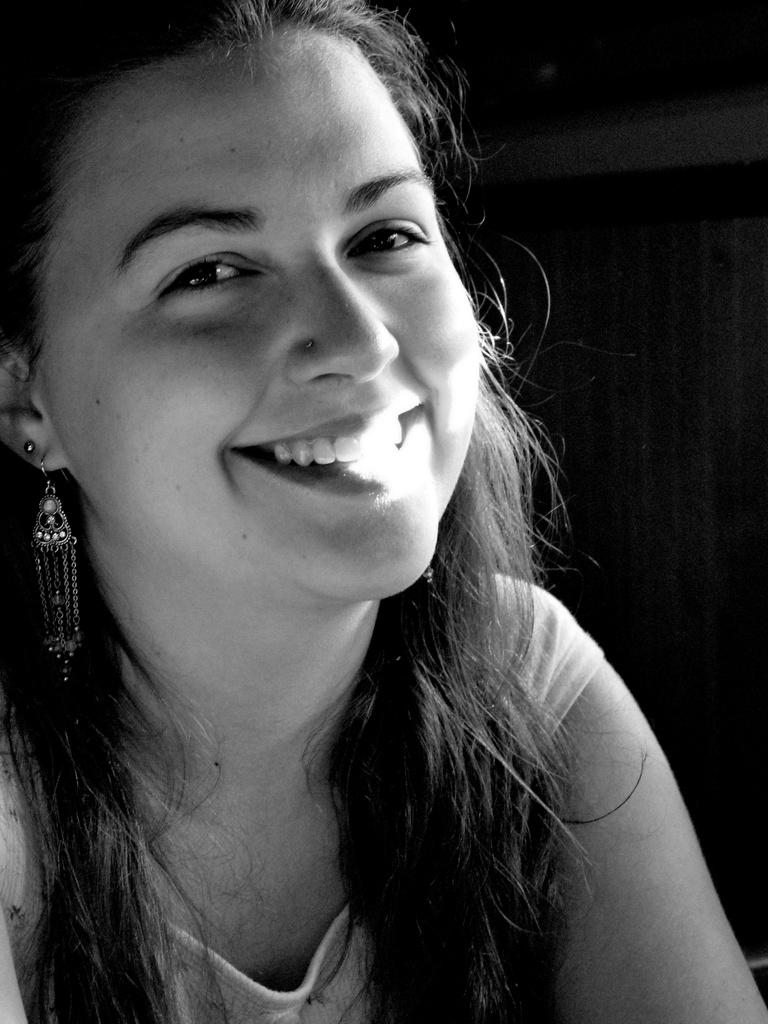What is the color scheme of the image? The image is black and white. Can you describe the main subject in the image? There is a woman in the image. How many cats are visible on the side of the woman in the image? There are no cats present in the image. What type of coat is the woman wearing in the image? The image is black and white, so it is not possible to determine the type of coat the woman might be wearing. 